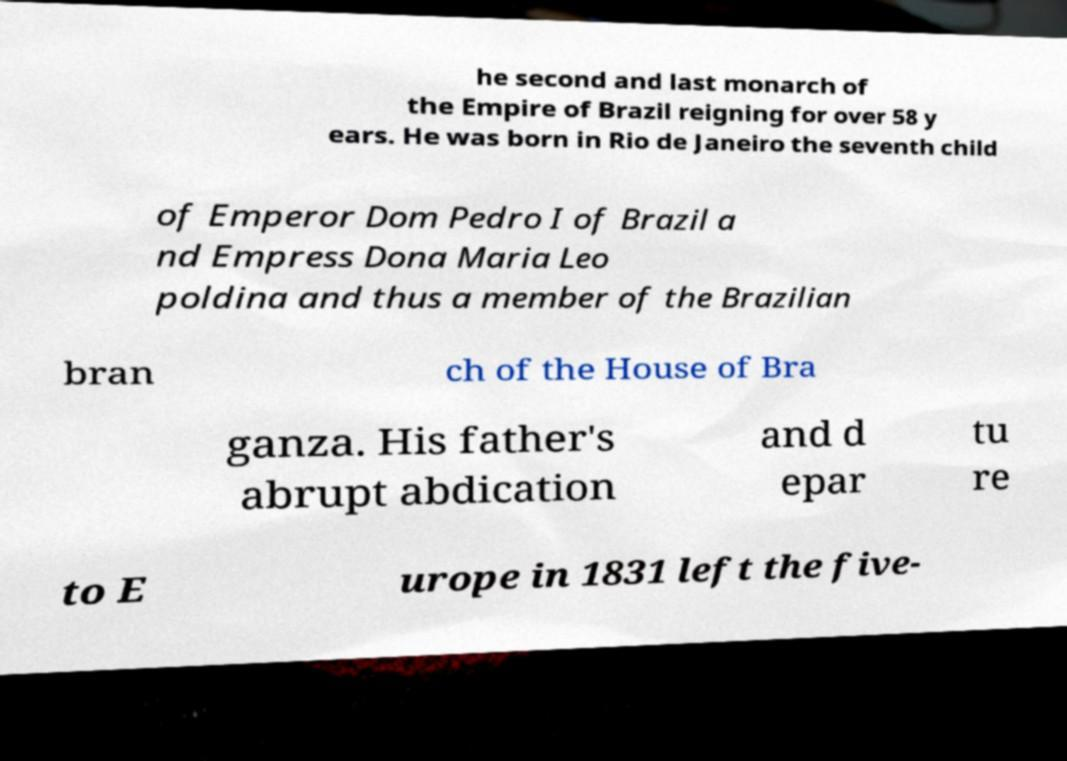Could you assist in decoding the text presented in this image and type it out clearly? he second and last monarch of the Empire of Brazil reigning for over 58 y ears. He was born in Rio de Janeiro the seventh child of Emperor Dom Pedro I of Brazil a nd Empress Dona Maria Leo poldina and thus a member of the Brazilian bran ch of the House of Bra ganza. His father's abrupt abdication and d epar tu re to E urope in 1831 left the five- 